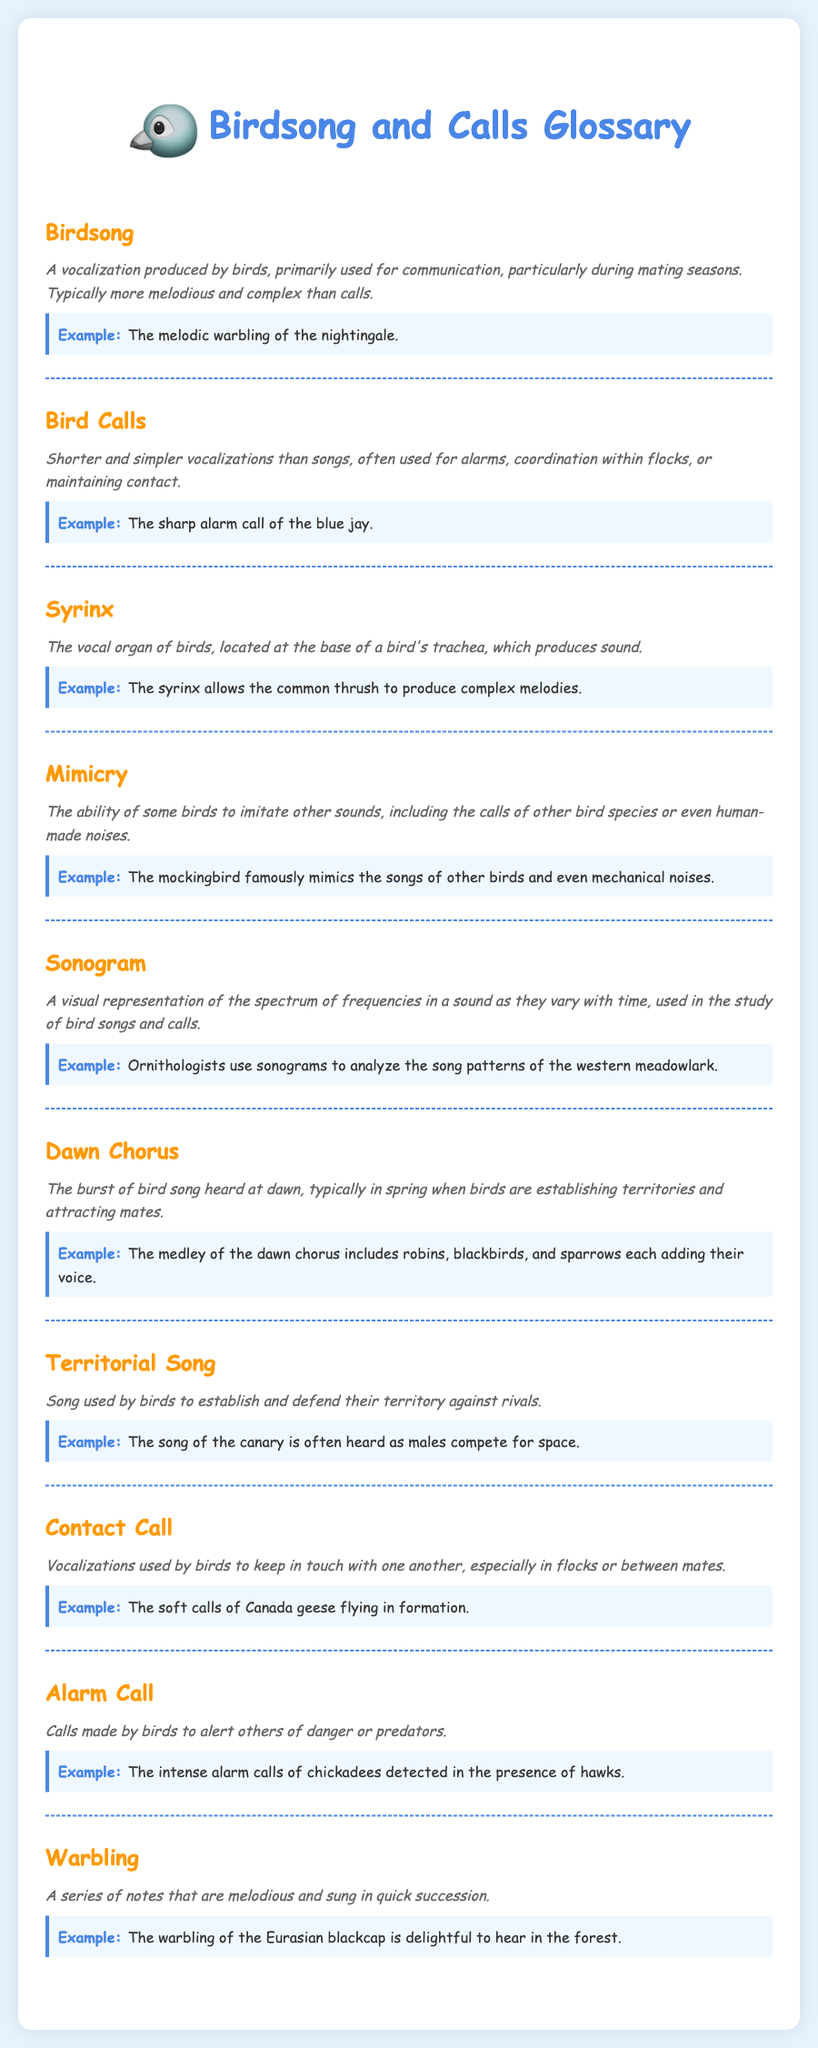What is the definition of birdsong? The definition describes birdsong as a vocalization produced by birds, primarily for communication during mating seasons, and that it is typically more melodious and complex than calls.
Answer: A vocalization produced by birds, primarily used for communication, particularly during mating seasons What is the example given for bird calls? The example illustrates a specific type of vocalization, highlighting the sharp alarm call of the blue jay.
Answer: The sharp alarm call of the blue jay What organ produces bird sounds? The document identifies the syrinx as the vocal organ of birds, located at the base of a bird's trachea.
Answer: Syrinx What ability do some birds have that involves imitating sounds? The term mimicry refers to the ability of some birds to imitate other sounds, including the calls of other bird species or human-made noises.
Answer: Mimicry What type of bird song is commonly heard at dawn? The term dawn chorus is used to describe the burst of bird song heard at dawn, especially in spring.
Answer: Dawn Chorus Which bird call is used by birds to alert others of danger? The document specifies alarm calls as the calls made by birds to warn others of danger or predators.
Answer: Alarm Call What is an example of a contact call? The document provides the example of soft calls of Canada geese flying in formation to illustrate contact calls.
Answer: The soft calls of Canada geese flying in formation What type of song do birds use to establish territory? The document clearly states that territorial songs are used by birds to establish and defend their territory against rivals.
Answer: Territorial Song What is the typical characteristic of warbling in bird song? Warbling is defined in the document as a series of melodious notes sung in quick succession.
Answer: A series of notes that are melodious and sung in quick succession 